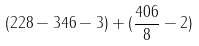Convert formula to latex. <formula><loc_0><loc_0><loc_500><loc_500>( 2 2 8 - 3 4 6 - 3 ) + ( \frac { 4 0 6 } { 8 } - 2 )</formula> 